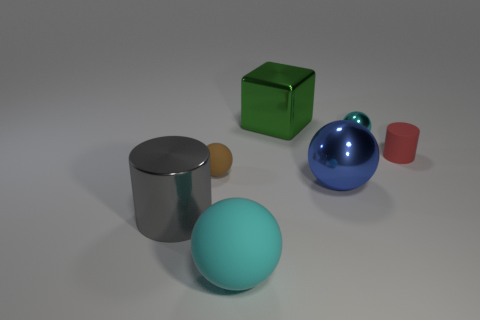Subtract all yellow spheres. Subtract all cyan cylinders. How many spheres are left? 4 Add 3 tiny yellow shiny objects. How many objects exist? 10 Subtract all spheres. How many objects are left? 3 Subtract 0 gray spheres. How many objects are left? 7 Subtract all large cyan things. Subtract all tiny gray shiny cylinders. How many objects are left? 6 Add 3 cyan spheres. How many cyan spheres are left? 5 Add 3 gray metallic cylinders. How many gray metallic cylinders exist? 4 